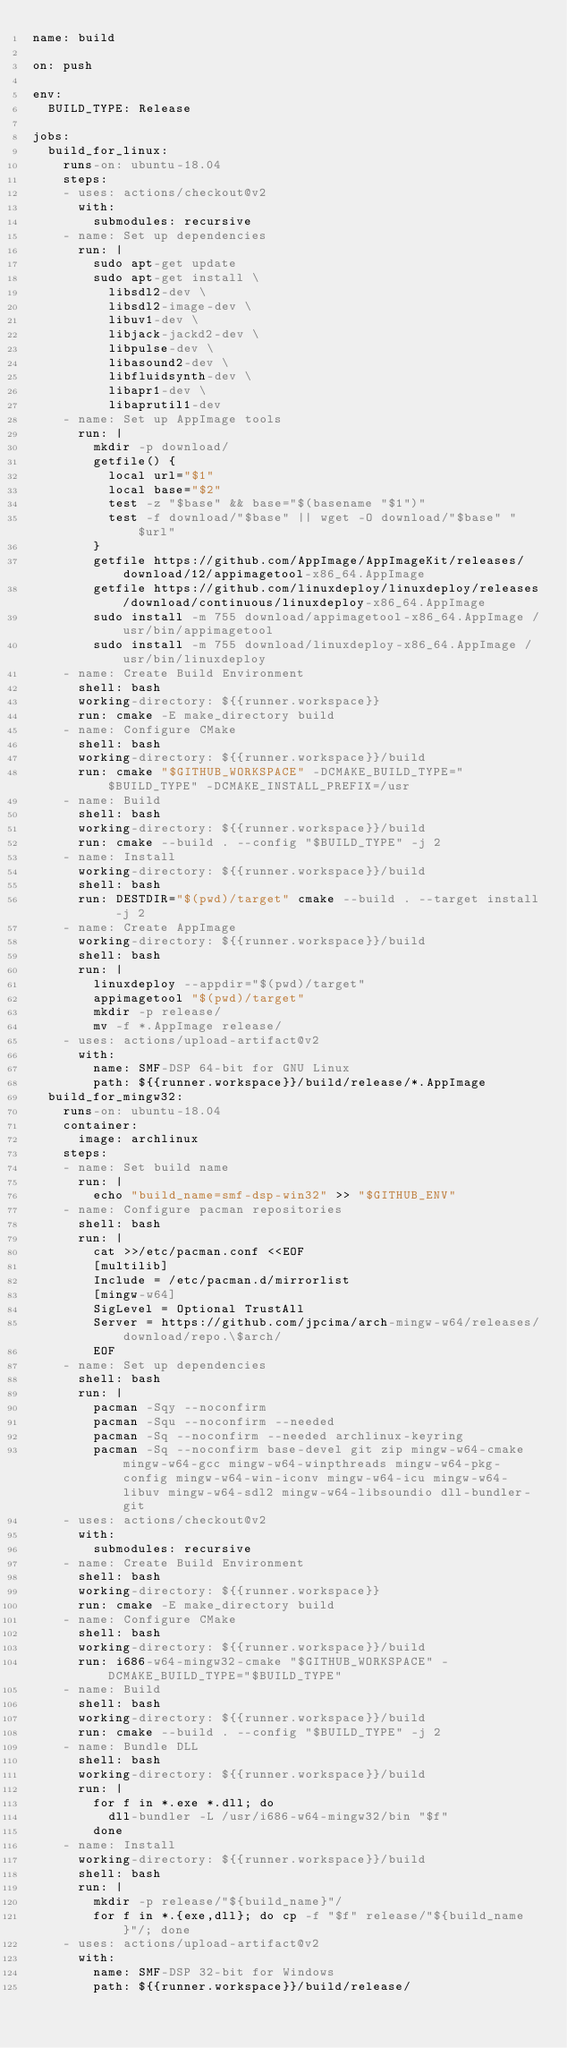<code> <loc_0><loc_0><loc_500><loc_500><_YAML_>name: build

on: push

env:
  BUILD_TYPE: Release

jobs:
  build_for_linux:
    runs-on: ubuntu-18.04
    steps:
    - uses: actions/checkout@v2
      with:
        submodules: recursive
    - name: Set up dependencies
      run: |
        sudo apt-get update
        sudo apt-get install \
          libsdl2-dev \
          libsdl2-image-dev \
          libuv1-dev \
          libjack-jackd2-dev \
          libpulse-dev \
          libasound2-dev \
          libfluidsynth-dev \
          libapr1-dev \
          libaprutil1-dev
    - name: Set up AppImage tools
      run: |
        mkdir -p download/
        getfile() {
          local url="$1"
          local base="$2"
          test -z "$base" && base="$(basename "$1")"
          test -f download/"$base" || wget -O download/"$base" "$url"
        }
        getfile https://github.com/AppImage/AppImageKit/releases/download/12/appimagetool-x86_64.AppImage
        getfile https://github.com/linuxdeploy/linuxdeploy/releases/download/continuous/linuxdeploy-x86_64.AppImage
        sudo install -m 755 download/appimagetool-x86_64.AppImage /usr/bin/appimagetool
        sudo install -m 755 download/linuxdeploy-x86_64.AppImage /usr/bin/linuxdeploy
    - name: Create Build Environment
      shell: bash
      working-directory: ${{runner.workspace}}
      run: cmake -E make_directory build
    - name: Configure CMake
      shell: bash
      working-directory: ${{runner.workspace}}/build
      run: cmake "$GITHUB_WORKSPACE" -DCMAKE_BUILD_TYPE="$BUILD_TYPE" -DCMAKE_INSTALL_PREFIX=/usr
    - name: Build
      shell: bash
      working-directory: ${{runner.workspace}}/build
      run: cmake --build . --config "$BUILD_TYPE" -j 2
    - name: Install
      working-directory: ${{runner.workspace}}/build
      shell: bash
      run: DESTDIR="$(pwd)/target" cmake --build . --target install -j 2
    - name: Create AppImage
      working-directory: ${{runner.workspace}}/build
      shell: bash
      run: |
        linuxdeploy --appdir="$(pwd)/target"
        appimagetool "$(pwd)/target"
        mkdir -p release/
        mv -f *.AppImage release/
    - uses: actions/upload-artifact@v2
      with:
        name: SMF-DSP 64-bit for GNU Linux
        path: ${{runner.workspace}}/build/release/*.AppImage
  build_for_mingw32:
    runs-on: ubuntu-18.04
    container:
      image: archlinux
    steps:
    - name: Set build name
      run: |
        echo "build_name=smf-dsp-win32" >> "$GITHUB_ENV"
    - name: Configure pacman repositories
      shell: bash
      run: |
        cat >>/etc/pacman.conf <<EOF
        [multilib]
        Include = /etc/pacman.d/mirrorlist
        [mingw-w64]
        SigLevel = Optional TrustAll
        Server = https://github.com/jpcima/arch-mingw-w64/releases/download/repo.\$arch/
        EOF
    - name: Set up dependencies
      shell: bash
      run: |
        pacman -Sqy --noconfirm
        pacman -Squ --noconfirm --needed
        pacman -Sq --noconfirm --needed archlinux-keyring
        pacman -Sq --noconfirm base-devel git zip mingw-w64-cmake mingw-w64-gcc mingw-w64-winpthreads mingw-w64-pkg-config mingw-w64-win-iconv mingw-w64-icu mingw-w64-libuv mingw-w64-sdl2 mingw-w64-libsoundio dll-bundler-git
    - uses: actions/checkout@v2
      with:
        submodules: recursive
    - name: Create Build Environment
      shell: bash
      working-directory: ${{runner.workspace}}
      run: cmake -E make_directory build
    - name: Configure CMake
      shell: bash
      working-directory: ${{runner.workspace}}/build
      run: i686-w64-mingw32-cmake "$GITHUB_WORKSPACE" -DCMAKE_BUILD_TYPE="$BUILD_TYPE"
    - name: Build
      shell: bash
      working-directory: ${{runner.workspace}}/build
      run: cmake --build . --config "$BUILD_TYPE" -j 2
    - name: Bundle DLL
      shell: bash
      working-directory: ${{runner.workspace}}/build
      run: |
        for f in *.exe *.dll; do
          dll-bundler -L /usr/i686-w64-mingw32/bin "$f"
        done
    - name: Install
      working-directory: ${{runner.workspace}}/build
      shell: bash
      run: |
        mkdir -p release/"${build_name}"/
        for f in *.{exe,dll}; do cp -f "$f" release/"${build_name}"/; done
    - uses: actions/upload-artifact@v2
      with:
        name: SMF-DSP 32-bit for Windows
        path: ${{runner.workspace}}/build/release/
</code> 